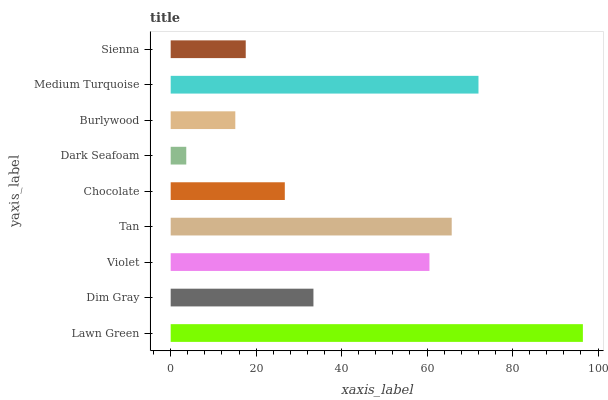Is Dark Seafoam the minimum?
Answer yes or no. Yes. Is Lawn Green the maximum?
Answer yes or no. Yes. Is Dim Gray the minimum?
Answer yes or no. No. Is Dim Gray the maximum?
Answer yes or no. No. Is Lawn Green greater than Dim Gray?
Answer yes or no. Yes. Is Dim Gray less than Lawn Green?
Answer yes or no. Yes. Is Dim Gray greater than Lawn Green?
Answer yes or no. No. Is Lawn Green less than Dim Gray?
Answer yes or no. No. Is Dim Gray the high median?
Answer yes or no. Yes. Is Dim Gray the low median?
Answer yes or no. Yes. Is Violet the high median?
Answer yes or no. No. Is Burlywood the low median?
Answer yes or no. No. 